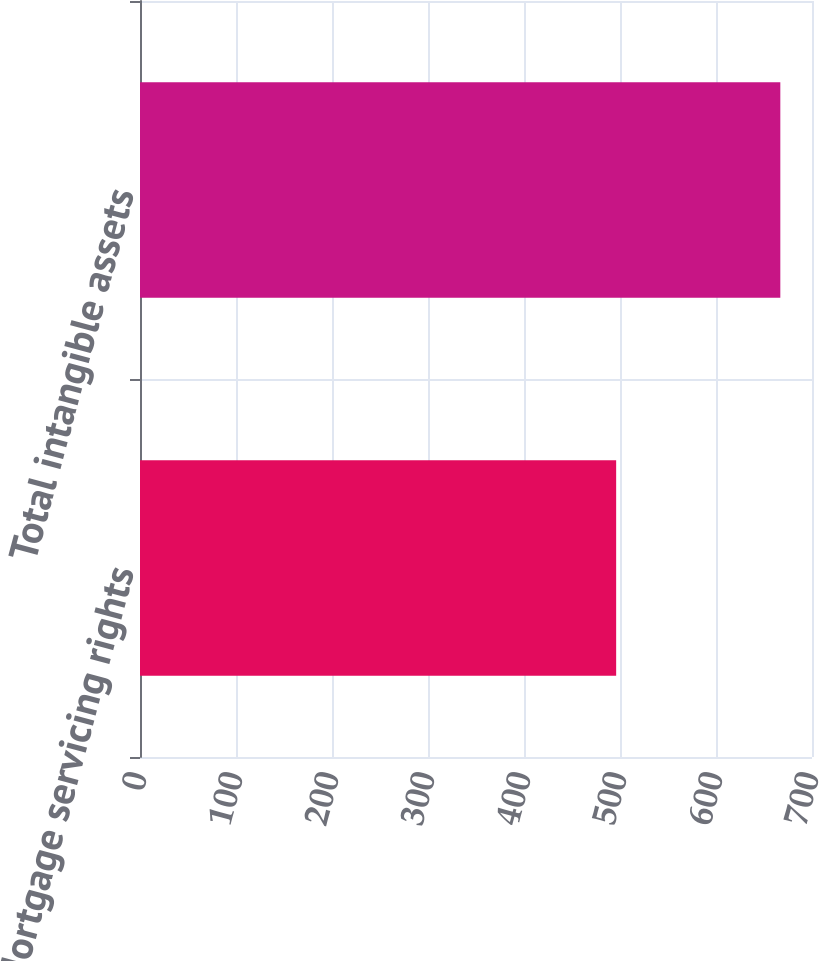Convert chart. <chart><loc_0><loc_0><loc_500><loc_500><bar_chart><fcel>Mortgage servicing rights<fcel>Total intangible assets<nl><fcel>496<fcel>667<nl></chart> 